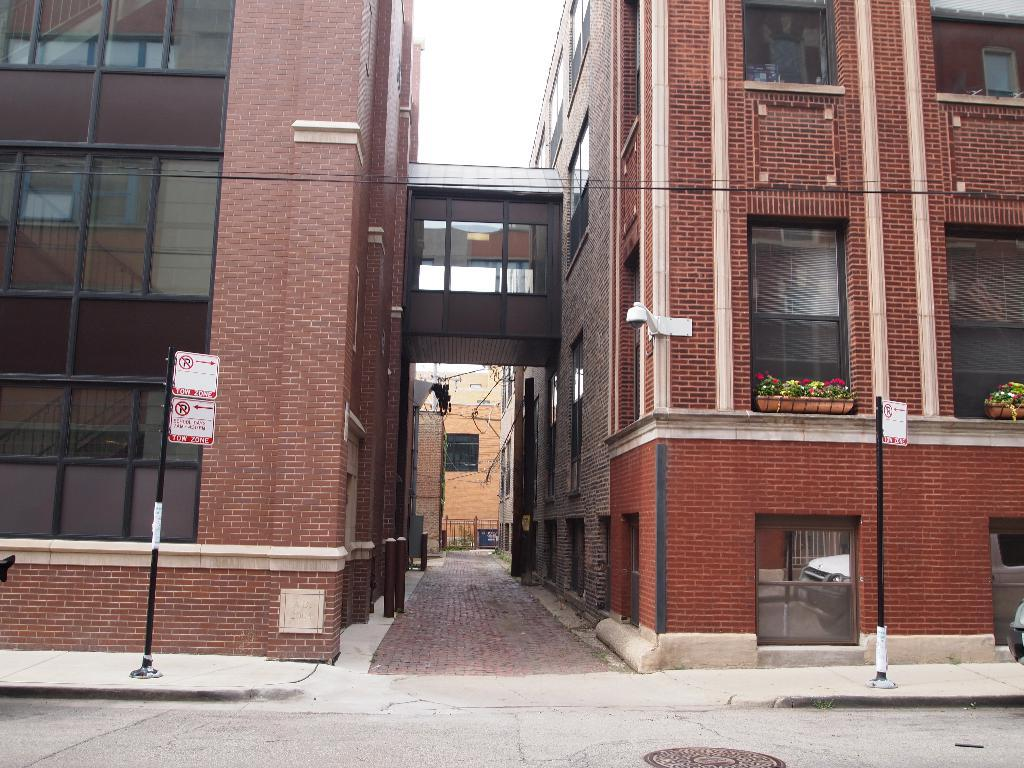What type of structures can be seen in the image? There are buildings in the image. What part of the natural environment is visible in the image? The sky is visible in the image. What are the poles used for in the image? The poles are likely used for supporting sign boards or other objects in the image. What can be seen on the poles in the image? Sign boards are present in the image. What type of pathway is visible in the image? There is a road in the image. What type of vegetation is visible in the image? House plants are visible in the image. How many pies are being sold by the fairies on the boats in the image? There are no pies, fairies, or boats present in the image. 